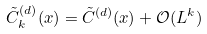Convert formula to latex. <formula><loc_0><loc_0><loc_500><loc_500>\tilde { C } _ { k } ^ { ( d ) } ( x ) = \tilde { C } ^ { ( d ) } ( x ) + \mathcal { O } ( L ^ { k } )</formula> 